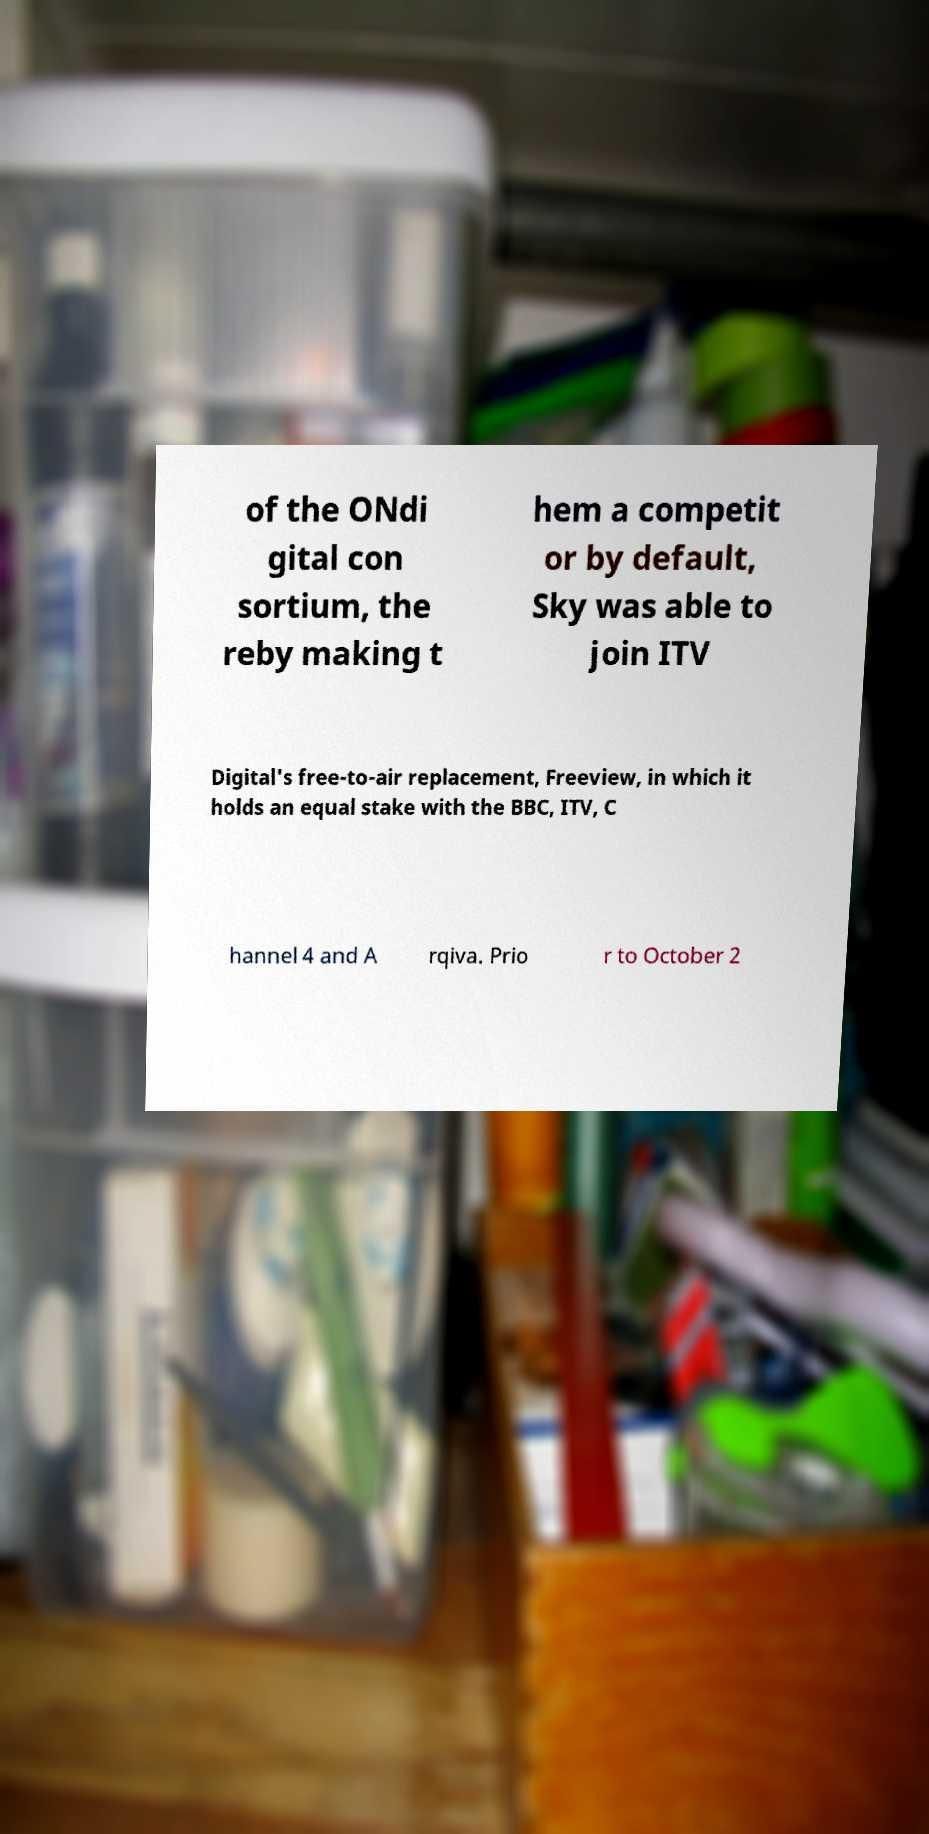For documentation purposes, I need the text within this image transcribed. Could you provide that? of the ONdi gital con sortium, the reby making t hem a competit or by default, Sky was able to join ITV Digital's free-to-air replacement, Freeview, in which it holds an equal stake with the BBC, ITV, C hannel 4 and A rqiva. Prio r to October 2 